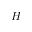<formula> <loc_0><loc_0><loc_500><loc_500>H</formula> 